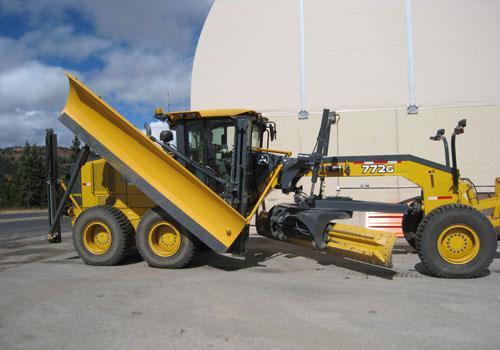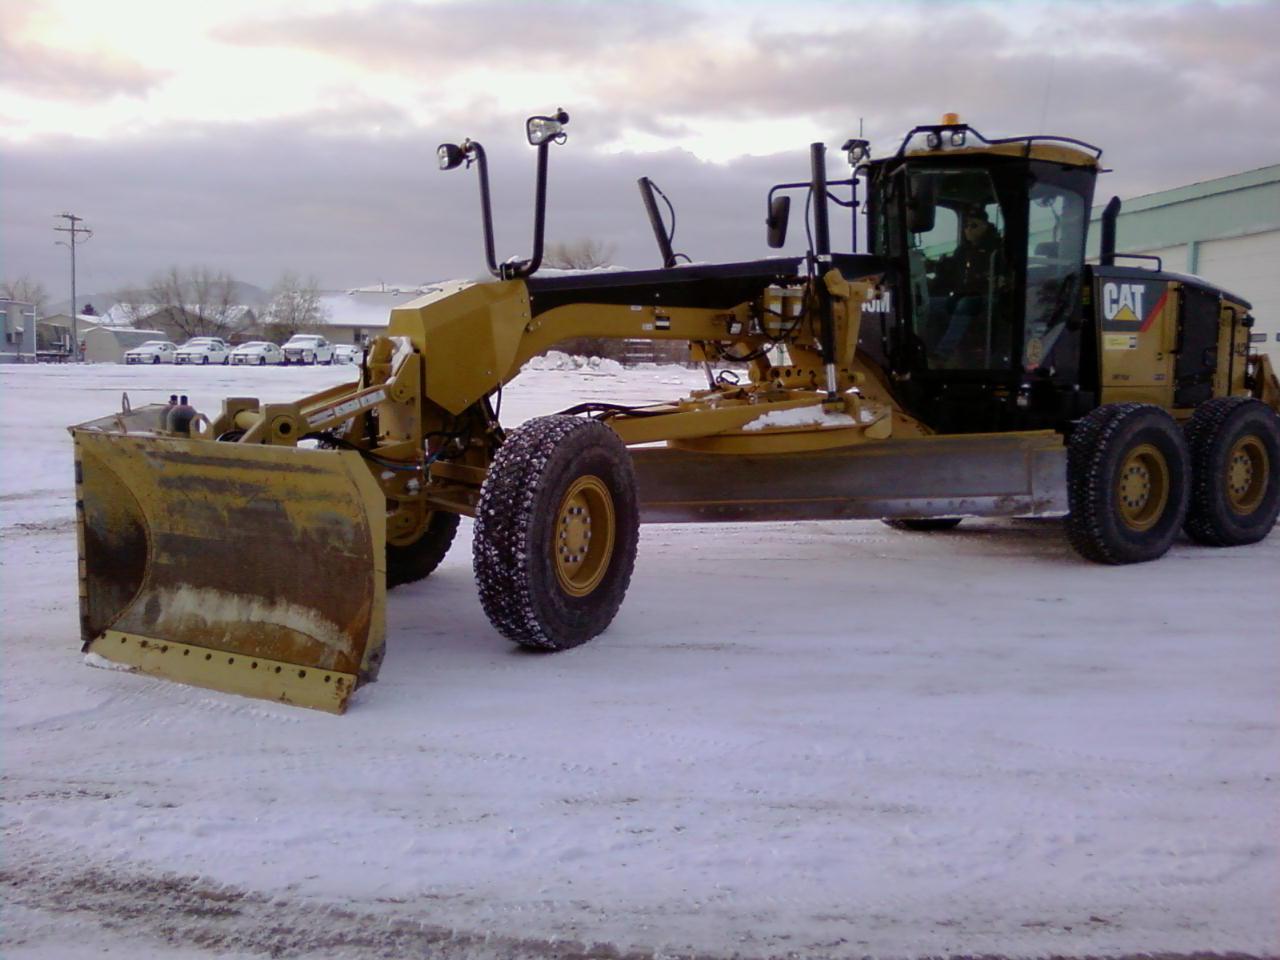The first image is the image on the left, the second image is the image on the right. For the images shown, is this caption "The equipment in both images is yellow, but one is parked on a snowy surface, while the other is not." true? Answer yes or no. Yes. The first image is the image on the left, the second image is the image on the right. Analyze the images presented: Is the assertion "The plow on the tractor on the right side is grey." valid? Answer yes or no. No. 